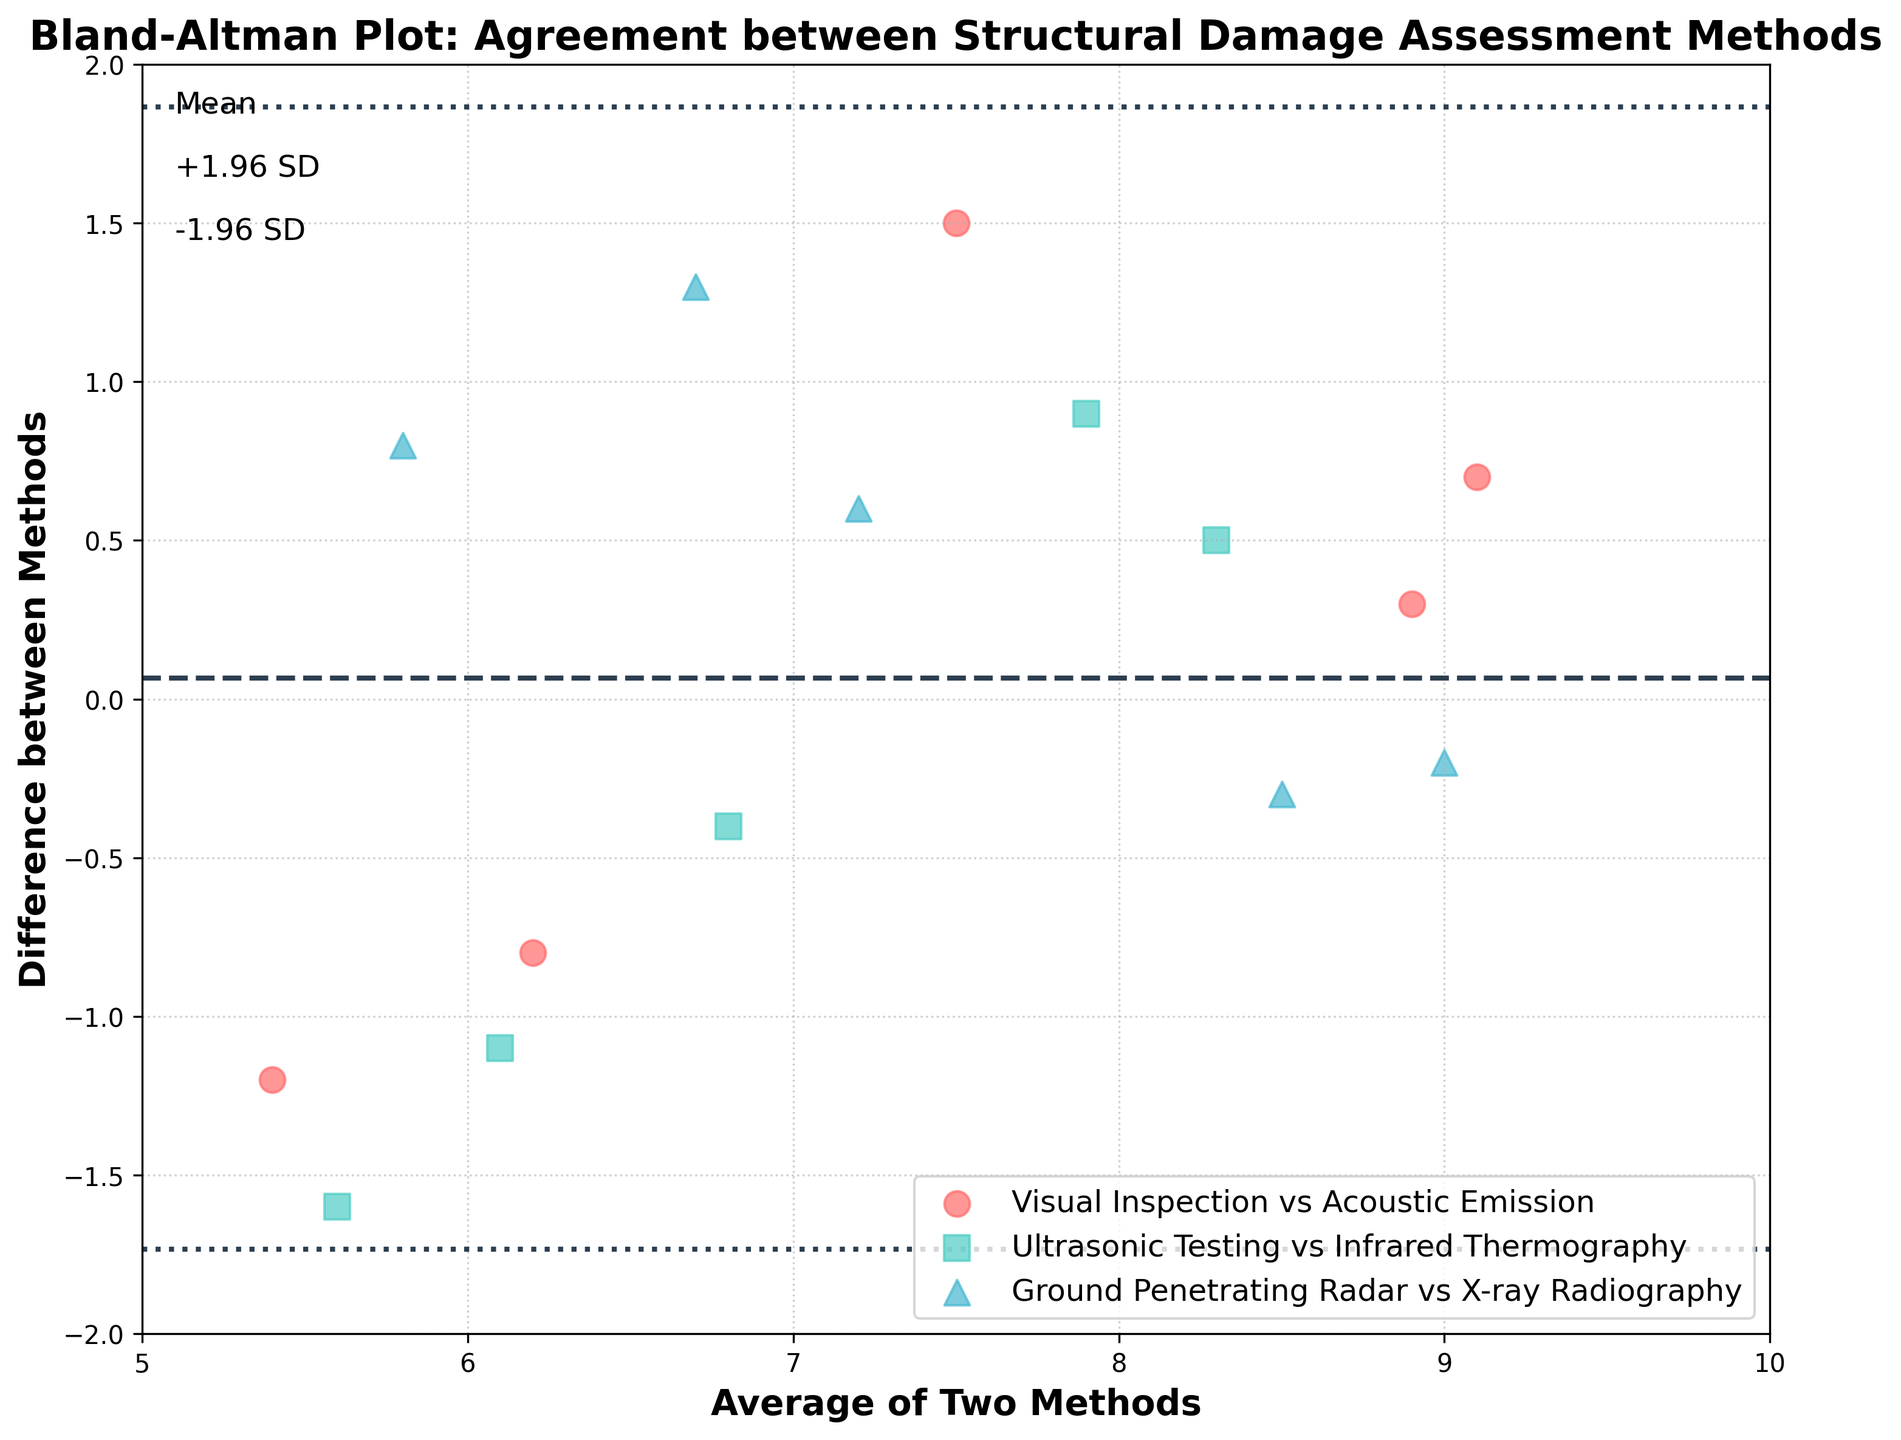How many unique methods are assessed in this plot? By looking at the legend in the figure, we can see that there are three unique methods assessed: Visual Inspection, Ultrasonic Testing, and Ground Penetrating Radar.
Answer: 3 What do the dashed lines represent on the plot? The dashed lines represent the mean difference between the methods, and the lines representing ±1.96 times the standard deviation from the mean difference.
Answer: Mean Diff. and ±1.96 SD Which pair of methods shows the largest average difference? By analyzing the scatter points and their positions, we observe that Visual Inspection vs Acoustic Emission has the largest average difference since more of its points are further from zero.
Answer: Visual Inspection vs Acoustic Emission What is the x-axis label and its range? The x-axis label is 'Average of Two Methods', and its range spans from 5 to 10 as noted from the axis ticks.
Answer: Average of Two Methods, 5 to 10 Explain what it means if a data point is above the mean difference line. If a data point is above the mean difference line, it indicates that for that specific measurement pair, the first method resulted in a higher value than the second method by more than the average difference.
Answer: Higher value by more than average difference How many data points are there with a difference greater than 1? To find this, count the number of points above the horizontal line at 1. By inspecting the plot, there are two such points.
Answer: 2 Which method pair exhibits the smallest standard deviation of differences? Observing the spread of the scatter points for each pair and comparing, Ground Penetrating Radar vs X-ray Radiography seems to exhibit the smallest standard deviation since their points are more tightly clustered.
Answer: Ground Penetrating Radar vs X-ray Radiography What are the color and marker used for the Ultrasonic Testing pair in the plot? The color used for Ultrasonic Testing is a teal green, and the marker is a square.
Answer: Teal, Square What signifies the +1.96 SD and -1.96 SD lines, and how are they calculated? The +1.96 SD and -1.96 SD lines on the plot represent the bounds within which approximately 95% of the differences between methods should lie, calculated as: mean difference ± 1.96 times the standard deviation of the differences.
Answer: Mean Difference ± 1.96 SD Which method pair has more data points on the positive side of the difference axis? By visually comparing, Visual Inspection vs Acoustic Emission has more data points above the zero difference axis.
Answer: Visual Inspection vs Acoustic Emission 